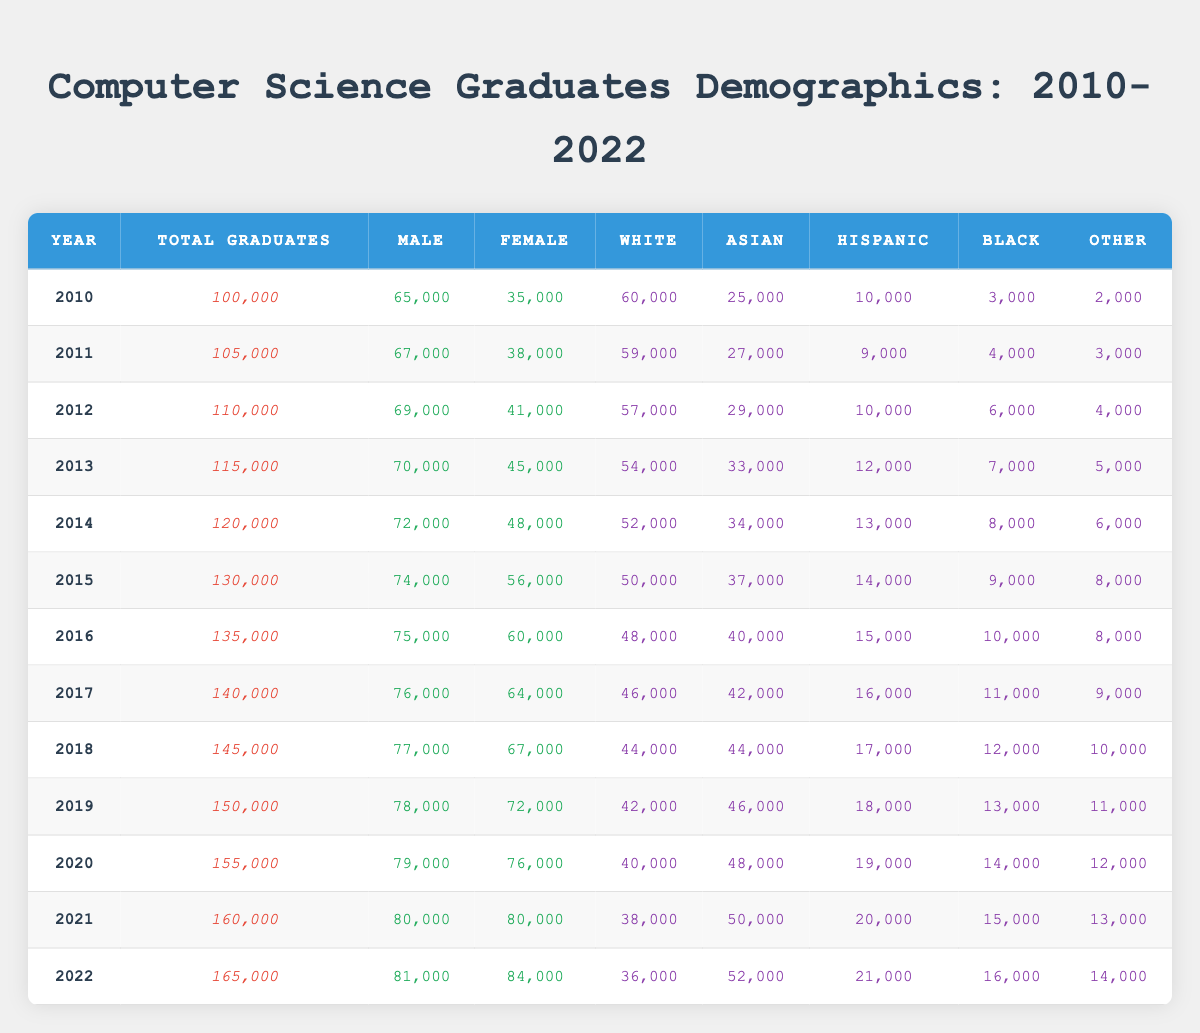What was the total number of graduates in 2015? The table shows that in 2015, the total graduates are listed under the "Total Graduates" column, which states 130,000.
Answer: 130,000 In which year did the number of female graduates exceed 70,000 for the first time? By examining the female graduates column, we see that the number first exceeds 70,000 in 2019, when there were 72,000 female graduates.
Answer: 2019 What percentage of total graduates were female in 2021? To calculate this, we take the number of female graduates in 2021, which is 80,000, and divide it by the total graduates, which is 160,000. (80,000 / 160,000) * 100 = 50%.
Answer: 50% What was the increase in total graduates from 2010 to 2022? The difference in the total graduates between these two years can be calculated by subtracting the total in 2010 (100,000) from the total in 2022 (165,000). So, 165,000 - 100,000 = 65,000.
Answer: 65,000 Did the number of Black graduates increase every year from 2010 to 2022? By checking the Black graduates column, we notice that in 2011 there were 3,000 Black graduates, and it increased every year until 2015, where it is 9,000. However, it dropped to 8,000 in 2014, making the statement false.
Answer: No What is the average number of Asian graduates from 2010 to 2022? To find the average, we sum the Asian graduates from each year and divide by the total years (13 years). The total is (25,000 + 27,000 + 29,000 + 33,000 + 34,000 + 37,000 + 42,000 + 44,000 + 46,000 + 48,000 + 50,000 + 52,000) = 502,000. Dividing by 13 gives us approximately 38,615.
Answer: 38,615 What was the greatest number of female graduates in a single year? By looking at the female graduates column, we see that 2022 has the highest number, 84,000.
Answer: 84,000 In 2019, what was the male-to-female ratio among graduates? For 2019, there were 78,000 male graduates and 72,000 female graduates. We calculate the ratio by dividing the number of males by females (78,000 / 72,000), which simplifies to 1.08.
Answer: 1.08 How many more Hispanic graduates were there in 2022 than in 2010? We see that in 2022, there were 21,000 Hispanic graduates and in 2010, there were 10,000. The difference is 21,000 - 10,000 = 11,000.
Answer: 11,000 Which year had the least number of graduates from the 'Other' ethnic group? The least number of graduates from the 'Other' group can be found by checking the relevant column, where in 2010, there were 2,000, which is the lowest across the years reviewed.
Answer: 2010 What trend can be observed in the total number of graduates from 2010 to 2022? The trend shows a consistent increase in the total number of graduates every year from 100,000 in 2010 to 165,000 in 2022, indicating growth in the computer science field during this period.
Answer: Consistent increase 